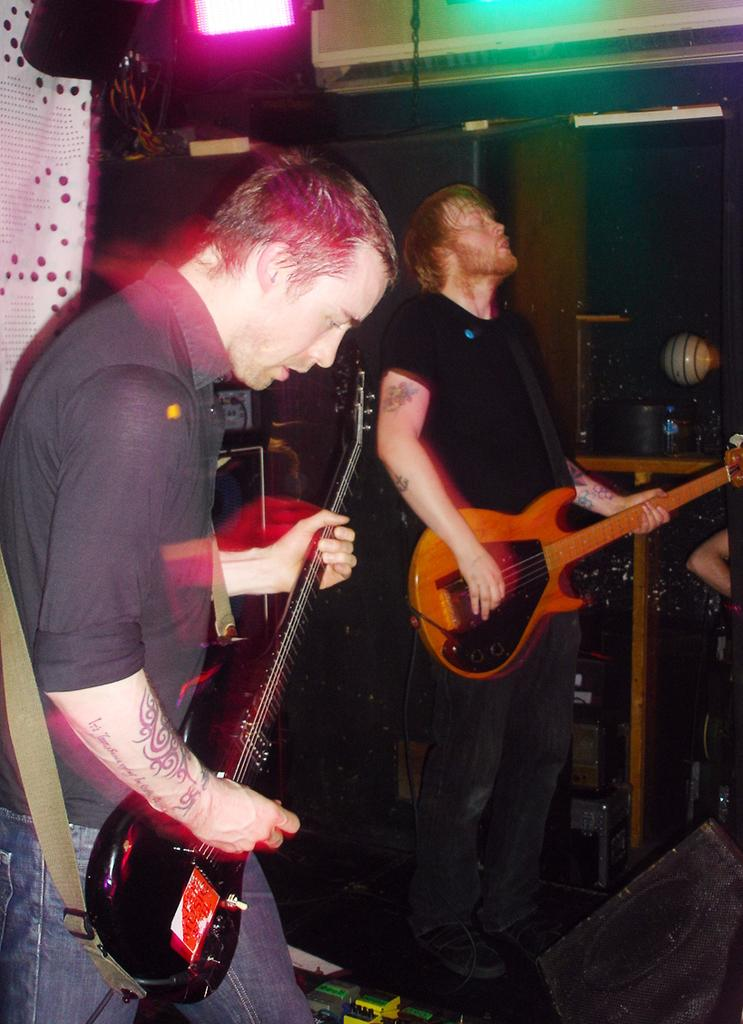How many people are in the image? There are two men in the image. What are the men doing in the image? The men are holding guitars and playing them. What can be seen in the background of the image? There is cloth and light visible in the background. Can you tell me which girl is driving the car in the image? There is no girl or car present in the image; it features two men playing guitars. 